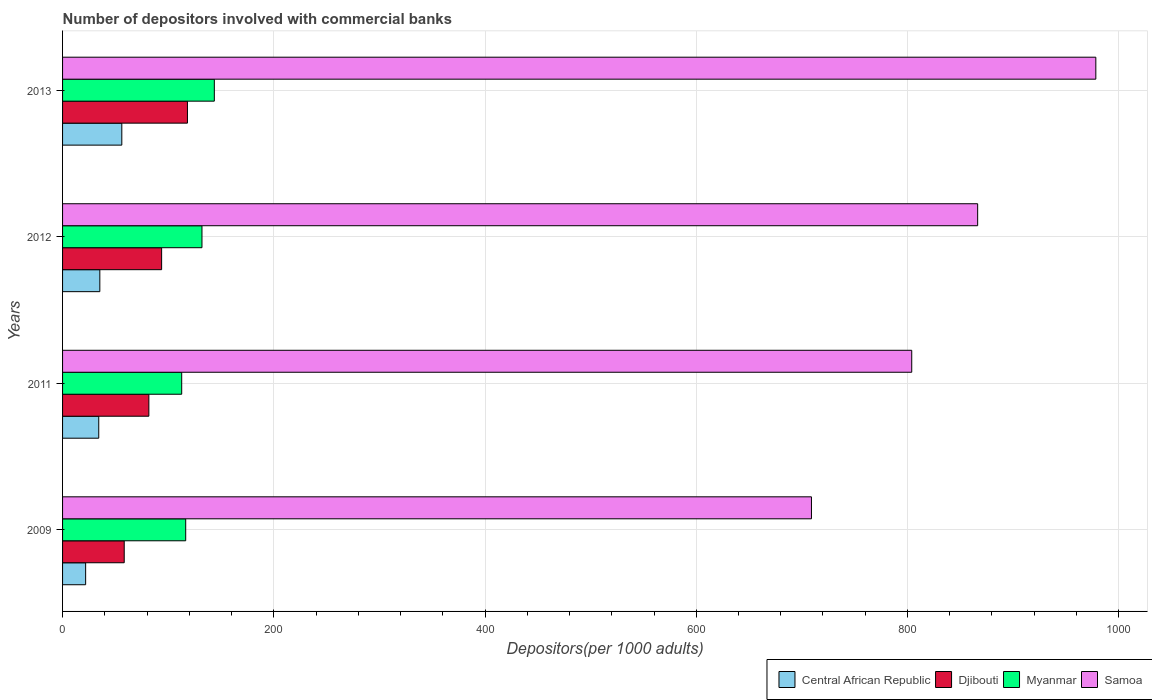Are the number of bars per tick equal to the number of legend labels?
Your answer should be compact. Yes. How many bars are there on the 4th tick from the top?
Provide a succinct answer. 4. How many bars are there on the 3rd tick from the bottom?
Keep it short and to the point. 4. What is the label of the 3rd group of bars from the top?
Keep it short and to the point. 2011. In how many cases, is the number of bars for a given year not equal to the number of legend labels?
Provide a succinct answer. 0. What is the number of depositors involved with commercial banks in Samoa in 2011?
Ensure brevity in your answer.  804.04. Across all years, what is the maximum number of depositors involved with commercial banks in Central African Republic?
Your answer should be very brief. 56.1. Across all years, what is the minimum number of depositors involved with commercial banks in Central African Republic?
Provide a short and direct response. 21.85. In which year was the number of depositors involved with commercial banks in Myanmar maximum?
Give a very brief answer. 2013. What is the total number of depositors involved with commercial banks in Myanmar in the graph?
Give a very brief answer. 505.07. What is the difference between the number of depositors involved with commercial banks in Samoa in 2009 and that in 2011?
Give a very brief answer. -94.95. What is the difference between the number of depositors involved with commercial banks in Samoa in 2009 and the number of depositors involved with commercial banks in Central African Republic in 2013?
Offer a very short reply. 652.99. What is the average number of depositors involved with commercial banks in Samoa per year?
Provide a succinct answer. 839.48. In the year 2012, what is the difference between the number of depositors involved with commercial banks in Djibouti and number of depositors involved with commercial banks in Myanmar?
Provide a short and direct response. -38.19. What is the ratio of the number of depositors involved with commercial banks in Central African Republic in 2011 to that in 2012?
Ensure brevity in your answer.  0.97. What is the difference between the highest and the second highest number of depositors involved with commercial banks in Central African Republic?
Provide a succinct answer. 20.82. What is the difference between the highest and the lowest number of depositors involved with commercial banks in Samoa?
Offer a terse response. 269.26. Is the sum of the number of depositors involved with commercial banks in Myanmar in 2009 and 2011 greater than the maximum number of depositors involved with commercial banks in Central African Republic across all years?
Your answer should be very brief. Yes. Is it the case that in every year, the sum of the number of depositors involved with commercial banks in Central African Republic and number of depositors involved with commercial banks in Myanmar is greater than the sum of number of depositors involved with commercial banks in Djibouti and number of depositors involved with commercial banks in Samoa?
Your response must be concise. No. What does the 2nd bar from the top in 2012 represents?
Keep it short and to the point. Myanmar. What does the 1st bar from the bottom in 2012 represents?
Give a very brief answer. Central African Republic. Is it the case that in every year, the sum of the number of depositors involved with commercial banks in Djibouti and number of depositors involved with commercial banks in Central African Republic is greater than the number of depositors involved with commercial banks in Samoa?
Your answer should be very brief. No. How many bars are there?
Ensure brevity in your answer.  16. Are all the bars in the graph horizontal?
Make the answer very short. Yes. Does the graph contain any zero values?
Your response must be concise. No. Does the graph contain grids?
Provide a short and direct response. Yes. How many legend labels are there?
Keep it short and to the point. 4. How are the legend labels stacked?
Offer a very short reply. Horizontal. What is the title of the graph?
Ensure brevity in your answer.  Number of depositors involved with commercial banks. Does "Thailand" appear as one of the legend labels in the graph?
Ensure brevity in your answer.  No. What is the label or title of the X-axis?
Your answer should be compact. Depositors(per 1000 adults). What is the Depositors(per 1000 adults) in Central African Republic in 2009?
Your response must be concise. 21.85. What is the Depositors(per 1000 adults) of Djibouti in 2009?
Provide a short and direct response. 58.37. What is the Depositors(per 1000 adults) of Myanmar in 2009?
Provide a succinct answer. 116.59. What is the Depositors(per 1000 adults) in Samoa in 2009?
Your response must be concise. 709.09. What is the Depositors(per 1000 adults) in Central African Republic in 2011?
Offer a very short reply. 34.26. What is the Depositors(per 1000 adults) of Djibouti in 2011?
Provide a short and direct response. 81.7. What is the Depositors(per 1000 adults) of Myanmar in 2011?
Offer a terse response. 112.8. What is the Depositors(per 1000 adults) of Samoa in 2011?
Ensure brevity in your answer.  804.04. What is the Depositors(per 1000 adults) of Central African Republic in 2012?
Provide a short and direct response. 35.28. What is the Depositors(per 1000 adults) in Djibouti in 2012?
Offer a terse response. 93.79. What is the Depositors(per 1000 adults) of Myanmar in 2012?
Ensure brevity in your answer.  131.99. What is the Depositors(per 1000 adults) of Samoa in 2012?
Keep it short and to the point. 866.45. What is the Depositors(per 1000 adults) in Central African Republic in 2013?
Your answer should be compact. 56.1. What is the Depositors(per 1000 adults) in Djibouti in 2013?
Keep it short and to the point. 118.26. What is the Depositors(per 1000 adults) in Myanmar in 2013?
Offer a terse response. 143.69. What is the Depositors(per 1000 adults) in Samoa in 2013?
Provide a short and direct response. 978.35. Across all years, what is the maximum Depositors(per 1000 adults) in Central African Republic?
Ensure brevity in your answer.  56.1. Across all years, what is the maximum Depositors(per 1000 adults) of Djibouti?
Ensure brevity in your answer.  118.26. Across all years, what is the maximum Depositors(per 1000 adults) of Myanmar?
Give a very brief answer. 143.69. Across all years, what is the maximum Depositors(per 1000 adults) in Samoa?
Ensure brevity in your answer.  978.35. Across all years, what is the minimum Depositors(per 1000 adults) of Central African Republic?
Your answer should be very brief. 21.85. Across all years, what is the minimum Depositors(per 1000 adults) in Djibouti?
Your answer should be very brief. 58.37. Across all years, what is the minimum Depositors(per 1000 adults) in Myanmar?
Your answer should be very brief. 112.8. Across all years, what is the minimum Depositors(per 1000 adults) in Samoa?
Keep it short and to the point. 709.09. What is the total Depositors(per 1000 adults) of Central African Republic in the graph?
Your answer should be very brief. 147.48. What is the total Depositors(per 1000 adults) in Djibouti in the graph?
Offer a very short reply. 352.13. What is the total Depositors(per 1000 adults) of Myanmar in the graph?
Offer a very short reply. 505.07. What is the total Depositors(per 1000 adults) of Samoa in the graph?
Offer a terse response. 3357.94. What is the difference between the Depositors(per 1000 adults) of Central African Republic in 2009 and that in 2011?
Make the answer very short. -12.4. What is the difference between the Depositors(per 1000 adults) of Djibouti in 2009 and that in 2011?
Ensure brevity in your answer.  -23.33. What is the difference between the Depositors(per 1000 adults) of Myanmar in 2009 and that in 2011?
Your answer should be very brief. 3.79. What is the difference between the Depositors(per 1000 adults) of Samoa in 2009 and that in 2011?
Offer a very short reply. -94.95. What is the difference between the Depositors(per 1000 adults) in Central African Republic in 2009 and that in 2012?
Make the answer very short. -13.43. What is the difference between the Depositors(per 1000 adults) in Djibouti in 2009 and that in 2012?
Offer a terse response. -35.42. What is the difference between the Depositors(per 1000 adults) in Myanmar in 2009 and that in 2012?
Keep it short and to the point. -15.4. What is the difference between the Depositors(per 1000 adults) in Samoa in 2009 and that in 2012?
Provide a succinct answer. -157.36. What is the difference between the Depositors(per 1000 adults) in Central African Republic in 2009 and that in 2013?
Provide a succinct answer. -34.25. What is the difference between the Depositors(per 1000 adults) in Djibouti in 2009 and that in 2013?
Your answer should be compact. -59.88. What is the difference between the Depositors(per 1000 adults) of Myanmar in 2009 and that in 2013?
Offer a terse response. -27.11. What is the difference between the Depositors(per 1000 adults) of Samoa in 2009 and that in 2013?
Give a very brief answer. -269.26. What is the difference between the Depositors(per 1000 adults) in Central African Republic in 2011 and that in 2012?
Provide a succinct answer. -1.02. What is the difference between the Depositors(per 1000 adults) in Djibouti in 2011 and that in 2012?
Your response must be concise. -12.09. What is the difference between the Depositors(per 1000 adults) of Myanmar in 2011 and that in 2012?
Your answer should be compact. -19.19. What is the difference between the Depositors(per 1000 adults) in Samoa in 2011 and that in 2012?
Your answer should be very brief. -62.41. What is the difference between the Depositors(per 1000 adults) of Central African Republic in 2011 and that in 2013?
Offer a terse response. -21.84. What is the difference between the Depositors(per 1000 adults) of Djibouti in 2011 and that in 2013?
Keep it short and to the point. -36.55. What is the difference between the Depositors(per 1000 adults) of Myanmar in 2011 and that in 2013?
Ensure brevity in your answer.  -30.89. What is the difference between the Depositors(per 1000 adults) of Samoa in 2011 and that in 2013?
Your answer should be very brief. -174.3. What is the difference between the Depositors(per 1000 adults) of Central African Republic in 2012 and that in 2013?
Your answer should be compact. -20.82. What is the difference between the Depositors(per 1000 adults) of Djibouti in 2012 and that in 2013?
Give a very brief answer. -24.46. What is the difference between the Depositors(per 1000 adults) of Myanmar in 2012 and that in 2013?
Offer a very short reply. -11.71. What is the difference between the Depositors(per 1000 adults) in Samoa in 2012 and that in 2013?
Ensure brevity in your answer.  -111.9. What is the difference between the Depositors(per 1000 adults) of Central African Republic in 2009 and the Depositors(per 1000 adults) of Djibouti in 2011?
Make the answer very short. -59.85. What is the difference between the Depositors(per 1000 adults) of Central African Republic in 2009 and the Depositors(per 1000 adults) of Myanmar in 2011?
Keep it short and to the point. -90.95. What is the difference between the Depositors(per 1000 adults) of Central African Republic in 2009 and the Depositors(per 1000 adults) of Samoa in 2011?
Make the answer very short. -782.19. What is the difference between the Depositors(per 1000 adults) in Djibouti in 2009 and the Depositors(per 1000 adults) in Myanmar in 2011?
Your answer should be compact. -54.43. What is the difference between the Depositors(per 1000 adults) in Djibouti in 2009 and the Depositors(per 1000 adults) in Samoa in 2011?
Offer a very short reply. -745.67. What is the difference between the Depositors(per 1000 adults) in Myanmar in 2009 and the Depositors(per 1000 adults) in Samoa in 2011?
Your answer should be compact. -687.46. What is the difference between the Depositors(per 1000 adults) in Central African Republic in 2009 and the Depositors(per 1000 adults) in Djibouti in 2012?
Your answer should be compact. -71.94. What is the difference between the Depositors(per 1000 adults) in Central African Republic in 2009 and the Depositors(per 1000 adults) in Myanmar in 2012?
Your response must be concise. -110.14. What is the difference between the Depositors(per 1000 adults) in Central African Republic in 2009 and the Depositors(per 1000 adults) in Samoa in 2012?
Offer a very short reply. -844.6. What is the difference between the Depositors(per 1000 adults) in Djibouti in 2009 and the Depositors(per 1000 adults) in Myanmar in 2012?
Make the answer very short. -73.61. What is the difference between the Depositors(per 1000 adults) of Djibouti in 2009 and the Depositors(per 1000 adults) of Samoa in 2012?
Your answer should be very brief. -808.08. What is the difference between the Depositors(per 1000 adults) in Myanmar in 2009 and the Depositors(per 1000 adults) in Samoa in 2012?
Ensure brevity in your answer.  -749.86. What is the difference between the Depositors(per 1000 adults) of Central African Republic in 2009 and the Depositors(per 1000 adults) of Djibouti in 2013?
Provide a succinct answer. -96.41. What is the difference between the Depositors(per 1000 adults) of Central African Republic in 2009 and the Depositors(per 1000 adults) of Myanmar in 2013?
Your answer should be very brief. -121.84. What is the difference between the Depositors(per 1000 adults) of Central African Republic in 2009 and the Depositors(per 1000 adults) of Samoa in 2013?
Your answer should be very brief. -956.5. What is the difference between the Depositors(per 1000 adults) of Djibouti in 2009 and the Depositors(per 1000 adults) of Myanmar in 2013?
Offer a very short reply. -85.32. What is the difference between the Depositors(per 1000 adults) in Djibouti in 2009 and the Depositors(per 1000 adults) in Samoa in 2013?
Offer a very short reply. -919.97. What is the difference between the Depositors(per 1000 adults) in Myanmar in 2009 and the Depositors(per 1000 adults) in Samoa in 2013?
Make the answer very short. -861.76. What is the difference between the Depositors(per 1000 adults) in Central African Republic in 2011 and the Depositors(per 1000 adults) in Djibouti in 2012?
Your response must be concise. -59.54. What is the difference between the Depositors(per 1000 adults) in Central African Republic in 2011 and the Depositors(per 1000 adults) in Myanmar in 2012?
Your answer should be compact. -97.73. What is the difference between the Depositors(per 1000 adults) of Central African Republic in 2011 and the Depositors(per 1000 adults) of Samoa in 2012?
Your answer should be very brief. -832.2. What is the difference between the Depositors(per 1000 adults) of Djibouti in 2011 and the Depositors(per 1000 adults) of Myanmar in 2012?
Make the answer very short. -50.29. What is the difference between the Depositors(per 1000 adults) of Djibouti in 2011 and the Depositors(per 1000 adults) of Samoa in 2012?
Your answer should be compact. -784.75. What is the difference between the Depositors(per 1000 adults) of Myanmar in 2011 and the Depositors(per 1000 adults) of Samoa in 2012?
Provide a short and direct response. -753.65. What is the difference between the Depositors(per 1000 adults) of Central African Republic in 2011 and the Depositors(per 1000 adults) of Djibouti in 2013?
Offer a terse response. -84. What is the difference between the Depositors(per 1000 adults) in Central African Republic in 2011 and the Depositors(per 1000 adults) in Myanmar in 2013?
Provide a succinct answer. -109.44. What is the difference between the Depositors(per 1000 adults) of Central African Republic in 2011 and the Depositors(per 1000 adults) of Samoa in 2013?
Offer a terse response. -944.09. What is the difference between the Depositors(per 1000 adults) of Djibouti in 2011 and the Depositors(per 1000 adults) of Myanmar in 2013?
Offer a terse response. -61.99. What is the difference between the Depositors(per 1000 adults) of Djibouti in 2011 and the Depositors(per 1000 adults) of Samoa in 2013?
Provide a succinct answer. -896.65. What is the difference between the Depositors(per 1000 adults) of Myanmar in 2011 and the Depositors(per 1000 adults) of Samoa in 2013?
Ensure brevity in your answer.  -865.55. What is the difference between the Depositors(per 1000 adults) in Central African Republic in 2012 and the Depositors(per 1000 adults) in Djibouti in 2013?
Your response must be concise. -82.98. What is the difference between the Depositors(per 1000 adults) in Central African Republic in 2012 and the Depositors(per 1000 adults) in Myanmar in 2013?
Provide a short and direct response. -108.41. What is the difference between the Depositors(per 1000 adults) of Central African Republic in 2012 and the Depositors(per 1000 adults) of Samoa in 2013?
Provide a succinct answer. -943.07. What is the difference between the Depositors(per 1000 adults) in Djibouti in 2012 and the Depositors(per 1000 adults) in Myanmar in 2013?
Ensure brevity in your answer.  -49.9. What is the difference between the Depositors(per 1000 adults) of Djibouti in 2012 and the Depositors(per 1000 adults) of Samoa in 2013?
Offer a very short reply. -884.55. What is the difference between the Depositors(per 1000 adults) of Myanmar in 2012 and the Depositors(per 1000 adults) of Samoa in 2013?
Your answer should be very brief. -846.36. What is the average Depositors(per 1000 adults) in Central African Republic per year?
Offer a terse response. 36.87. What is the average Depositors(per 1000 adults) of Djibouti per year?
Provide a succinct answer. 88.03. What is the average Depositors(per 1000 adults) of Myanmar per year?
Your answer should be very brief. 126.27. What is the average Depositors(per 1000 adults) in Samoa per year?
Offer a very short reply. 839.48. In the year 2009, what is the difference between the Depositors(per 1000 adults) of Central African Republic and Depositors(per 1000 adults) of Djibouti?
Your response must be concise. -36.52. In the year 2009, what is the difference between the Depositors(per 1000 adults) of Central African Republic and Depositors(per 1000 adults) of Myanmar?
Your response must be concise. -94.74. In the year 2009, what is the difference between the Depositors(per 1000 adults) in Central African Republic and Depositors(per 1000 adults) in Samoa?
Ensure brevity in your answer.  -687.24. In the year 2009, what is the difference between the Depositors(per 1000 adults) in Djibouti and Depositors(per 1000 adults) in Myanmar?
Provide a short and direct response. -58.21. In the year 2009, what is the difference between the Depositors(per 1000 adults) of Djibouti and Depositors(per 1000 adults) of Samoa?
Offer a terse response. -650.72. In the year 2009, what is the difference between the Depositors(per 1000 adults) in Myanmar and Depositors(per 1000 adults) in Samoa?
Give a very brief answer. -592.5. In the year 2011, what is the difference between the Depositors(per 1000 adults) of Central African Republic and Depositors(per 1000 adults) of Djibouti?
Give a very brief answer. -47.45. In the year 2011, what is the difference between the Depositors(per 1000 adults) of Central African Republic and Depositors(per 1000 adults) of Myanmar?
Your answer should be compact. -78.54. In the year 2011, what is the difference between the Depositors(per 1000 adults) of Central African Republic and Depositors(per 1000 adults) of Samoa?
Ensure brevity in your answer.  -769.79. In the year 2011, what is the difference between the Depositors(per 1000 adults) in Djibouti and Depositors(per 1000 adults) in Myanmar?
Offer a very short reply. -31.1. In the year 2011, what is the difference between the Depositors(per 1000 adults) in Djibouti and Depositors(per 1000 adults) in Samoa?
Give a very brief answer. -722.34. In the year 2011, what is the difference between the Depositors(per 1000 adults) of Myanmar and Depositors(per 1000 adults) of Samoa?
Your response must be concise. -691.24. In the year 2012, what is the difference between the Depositors(per 1000 adults) of Central African Republic and Depositors(per 1000 adults) of Djibouti?
Make the answer very short. -58.51. In the year 2012, what is the difference between the Depositors(per 1000 adults) of Central African Republic and Depositors(per 1000 adults) of Myanmar?
Offer a very short reply. -96.71. In the year 2012, what is the difference between the Depositors(per 1000 adults) in Central African Republic and Depositors(per 1000 adults) in Samoa?
Your response must be concise. -831.17. In the year 2012, what is the difference between the Depositors(per 1000 adults) of Djibouti and Depositors(per 1000 adults) of Myanmar?
Offer a very short reply. -38.19. In the year 2012, what is the difference between the Depositors(per 1000 adults) in Djibouti and Depositors(per 1000 adults) in Samoa?
Keep it short and to the point. -772.66. In the year 2012, what is the difference between the Depositors(per 1000 adults) of Myanmar and Depositors(per 1000 adults) of Samoa?
Keep it short and to the point. -734.46. In the year 2013, what is the difference between the Depositors(per 1000 adults) in Central African Republic and Depositors(per 1000 adults) in Djibouti?
Keep it short and to the point. -62.16. In the year 2013, what is the difference between the Depositors(per 1000 adults) in Central African Republic and Depositors(per 1000 adults) in Myanmar?
Make the answer very short. -87.59. In the year 2013, what is the difference between the Depositors(per 1000 adults) in Central African Republic and Depositors(per 1000 adults) in Samoa?
Your answer should be compact. -922.25. In the year 2013, what is the difference between the Depositors(per 1000 adults) of Djibouti and Depositors(per 1000 adults) of Myanmar?
Provide a short and direct response. -25.44. In the year 2013, what is the difference between the Depositors(per 1000 adults) in Djibouti and Depositors(per 1000 adults) in Samoa?
Ensure brevity in your answer.  -860.09. In the year 2013, what is the difference between the Depositors(per 1000 adults) of Myanmar and Depositors(per 1000 adults) of Samoa?
Provide a short and direct response. -834.66. What is the ratio of the Depositors(per 1000 adults) in Central African Republic in 2009 to that in 2011?
Your response must be concise. 0.64. What is the ratio of the Depositors(per 1000 adults) in Djibouti in 2009 to that in 2011?
Offer a very short reply. 0.71. What is the ratio of the Depositors(per 1000 adults) of Myanmar in 2009 to that in 2011?
Offer a terse response. 1.03. What is the ratio of the Depositors(per 1000 adults) of Samoa in 2009 to that in 2011?
Offer a terse response. 0.88. What is the ratio of the Depositors(per 1000 adults) in Central African Republic in 2009 to that in 2012?
Keep it short and to the point. 0.62. What is the ratio of the Depositors(per 1000 adults) of Djibouti in 2009 to that in 2012?
Offer a very short reply. 0.62. What is the ratio of the Depositors(per 1000 adults) of Myanmar in 2009 to that in 2012?
Offer a terse response. 0.88. What is the ratio of the Depositors(per 1000 adults) of Samoa in 2009 to that in 2012?
Offer a terse response. 0.82. What is the ratio of the Depositors(per 1000 adults) of Central African Republic in 2009 to that in 2013?
Your answer should be very brief. 0.39. What is the ratio of the Depositors(per 1000 adults) of Djibouti in 2009 to that in 2013?
Provide a short and direct response. 0.49. What is the ratio of the Depositors(per 1000 adults) in Myanmar in 2009 to that in 2013?
Keep it short and to the point. 0.81. What is the ratio of the Depositors(per 1000 adults) of Samoa in 2009 to that in 2013?
Provide a succinct answer. 0.72. What is the ratio of the Depositors(per 1000 adults) of Central African Republic in 2011 to that in 2012?
Your response must be concise. 0.97. What is the ratio of the Depositors(per 1000 adults) in Djibouti in 2011 to that in 2012?
Make the answer very short. 0.87. What is the ratio of the Depositors(per 1000 adults) in Myanmar in 2011 to that in 2012?
Ensure brevity in your answer.  0.85. What is the ratio of the Depositors(per 1000 adults) of Samoa in 2011 to that in 2012?
Offer a terse response. 0.93. What is the ratio of the Depositors(per 1000 adults) of Central African Republic in 2011 to that in 2013?
Your answer should be compact. 0.61. What is the ratio of the Depositors(per 1000 adults) of Djibouti in 2011 to that in 2013?
Provide a succinct answer. 0.69. What is the ratio of the Depositors(per 1000 adults) in Myanmar in 2011 to that in 2013?
Provide a short and direct response. 0.79. What is the ratio of the Depositors(per 1000 adults) in Samoa in 2011 to that in 2013?
Provide a short and direct response. 0.82. What is the ratio of the Depositors(per 1000 adults) of Central African Republic in 2012 to that in 2013?
Keep it short and to the point. 0.63. What is the ratio of the Depositors(per 1000 adults) in Djibouti in 2012 to that in 2013?
Provide a succinct answer. 0.79. What is the ratio of the Depositors(per 1000 adults) of Myanmar in 2012 to that in 2013?
Provide a succinct answer. 0.92. What is the ratio of the Depositors(per 1000 adults) of Samoa in 2012 to that in 2013?
Provide a succinct answer. 0.89. What is the difference between the highest and the second highest Depositors(per 1000 adults) in Central African Republic?
Your answer should be very brief. 20.82. What is the difference between the highest and the second highest Depositors(per 1000 adults) in Djibouti?
Give a very brief answer. 24.46. What is the difference between the highest and the second highest Depositors(per 1000 adults) in Myanmar?
Ensure brevity in your answer.  11.71. What is the difference between the highest and the second highest Depositors(per 1000 adults) of Samoa?
Ensure brevity in your answer.  111.9. What is the difference between the highest and the lowest Depositors(per 1000 adults) in Central African Republic?
Offer a very short reply. 34.25. What is the difference between the highest and the lowest Depositors(per 1000 adults) of Djibouti?
Provide a succinct answer. 59.88. What is the difference between the highest and the lowest Depositors(per 1000 adults) in Myanmar?
Offer a terse response. 30.89. What is the difference between the highest and the lowest Depositors(per 1000 adults) in Samoa?
Offer a very short reply. 269.26. 